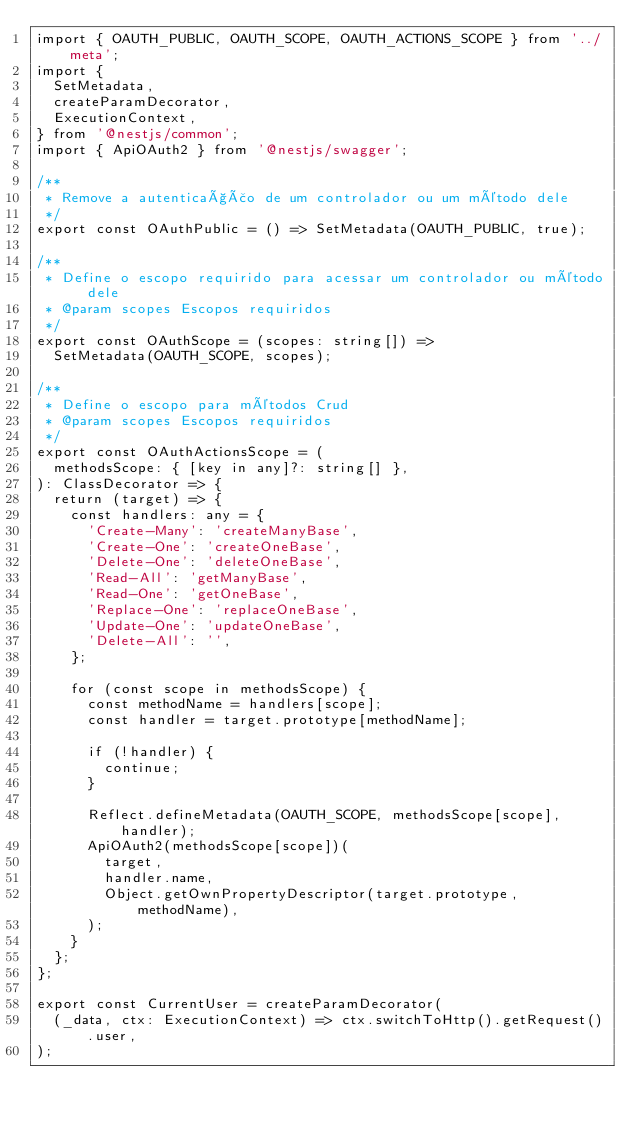<code> <loc_0><loc_0><loc_500><loc_500><_TypeScript_>import { OAUTH_PUBLIC, OAUTH_SCOPE, OAUTH_ACTIONS_SCOPE } from '../meta';
import {
  SetMetadata,
  createParamDecorator,
  ExecutionContext,
} from '@nestjs/common';
import { ApiOAuth2 } from '@nestjs/swagger';

/**
 * Remove a autenticação de um controlador ou um método dele
 */
export const OAuthPublic = () => SetMetadata(OAUTH_PUBLIC, true);

/**
 * Define o escopo requirido para acessar um controlador ou método dele
 * @param scopes Escopos requiridos
 */
export const OAuthScope = (scopes: string[]) =>
  SetMetadata(OAUTH_SCOPE, scopes);

/**
 * Define o escopo para métodos Crud
 * @param scopes Escopos requiridos
 */
export const OAuthActionsScope = (
  methodsScope: { [key in any]?: string[] },
): ClassDecorator => {
  return (target) => {
    const handlers: any = {
      'Create-Many': 'createManyBase',
      'Create-One': 'createOneBase',
      'Delete-One': 'deleteOneBase',
      'Read-All': 'getManyBase',
      'Read-One': 'getOneBase',
      'Replace-One': 'replaceOneBase',
      'Update-One': 'updateOneBase',
      'Delete-All': '',
    };

    for (const scope in methodsScope) {
      const methodName = handlers[scope];
      const handler = target.prototype[methodName];

      if (!handler) {
        continue;
      }

      Reflect.defineMetadata(OAUTH_SCOPE, methodsScope[scope], handler);
      ApiOAuth2(methodsScope[scope])(
        target,
        handler.name,
        Object.getOwnPropertyDescriptor(target.prototype, methodName),
      );
    }
  };
};

export const CurrentUser = createParamDecorator(
  (_data, ctx: ExecutionContext) => ctx.switchToHttp().getRequest().user,
);
</code> 